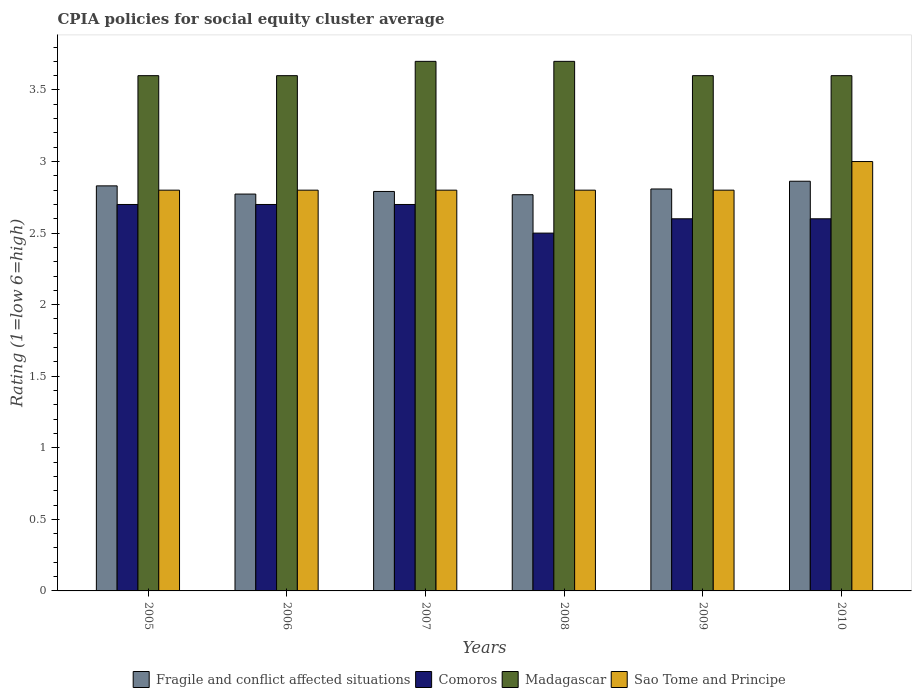How many groups of bars are there?
Provide a succinct answer. 6. Are the number of bars on each tick of the X-axis equal?
Your answer should be very brief. Yes. What is the label of the 6th group of bars from the left?
Offer a terse response. 2010. Across all years, what is the maximum CPIA rating in Fragile and conflict affected situations?
Your answer should be very brief. 2.86. Across all years, what is the minimum CPIA rating in Fragile and conflict affected situations?
Give a very brief answer. 2.77. In which year was the CPIA rating in Comoros minimum?
Make the answer very short. 2008. What is the total CPIA rating in Madagascar in the graph?
Your answer should be compact. 21.8. What is the difference between the CPIA rating in Sao Tome and Principe in 2005 and the CPIA rating in Madagascar in 2009?
Keep it short and to the point. -0.8. What is the average CPIA rating in Sao Tome and Principe per year?
Make the answer very short. 2.83. In the year 2009, what is the difference between the CPIA rating in Sao Tome and Principe and CPIA rating in Madagascar?
Your answer should be compact. -0.8. What is the ratio of the CPIA rating in Comoros in 2008 to that in 2009?
Ensure brevity in your answer.  0.96. Is the CPIA rating in Fragile and conflict affected situations in 2006 less than that in 2007?
Provide a short and direct response. Yes. What is the difference between the highest and the lowest CPIA rating in Sao Tome and Principe?
Provide a succinct answer. 0.2. Is the sum of the CPIA rating in Comoros in 2006 and 2010 greater than the maximum CPIA rating in Sao Tome and Principe across all years?
Your answer should be compact. Yes. What does the 2nd bar from the left in 2010 represents?
Provide a succinct answer. Comoros. What does the 3rd bar from the right in 2008 represents?
Provide a short and direct response. Comoros. Is it the case that in every year, the sum of the CPIA rating in Sao Tome and Principe and CPIA rating in Madagascar is greater than the CPIA rating in Comoros?
Your answer should be compact. Yes. How many years are there in the graph?
Your answer should be compact. 6. How are the legend labels stacked?
Keep it short and to the point. Horizontal. What is the title of the graph?
Your answer should be compact. CPIA policies for social equity cluster average. Does "Turks and Caicos Islands" appear as one of the legend labels in the graph?
Your answer should be compact. No. What is the Rating (1=low 6=high) of Fragile and conflict affected situations in 2005?
Provide a succinct answer. 2.83. What is the Rating (1=low 6=high) of Comoros in 2005?
Your answer should be very brief. 2.7. What is the Rating (1=low 6=high) of Madagascar in 2005?
Provide a succinct answer. 3.6. What is the Rating (1=low 6=high) of Sao Tome and Principe in 2005?
Your answer should be very brief. 2.8. What is the Rating (1=low 6=high) of Fragile and conflict affected situations in 2006?
Give a very brief answer. 2.77. What is the Rating (1=low 6=high) of Comoros in 2006?
Your answer should be very brief. 2.7. What is the Rating (1=low 6=high) in Sao Tome and Principe in 2006?
Your answer should be compact. 2.8. What is the Rating (1=low 6=high) in Fragile and conflict affected situations in 2007?
Your answer should be compact. 2.79. What is the Rating (1=low 6=high) of Madagascar in 2007?
Offer a terse response. 3.7. What is the Rating (1=low 6=high) of Fragile and conflict affected situations in 2008?
Your answer should be very brief. 2.77. What is the Rating (1=low 6=high) in Madagascar in 2008?
Your answer should be very brief. 3.7. What is the Rating (1=low 6=high) in Fragile and conflict affected situations in 2009?
Provide a short and direct response. 2.81. What is the Rating (1=low 6=high) in Comoros in 2009?
Give a very brief answer. 2.6. What is the Rating (1=low 6=high) in Fragile and conflict affected situations in 2010?
Your answer should be very brief. 2.86. What is the Rating (1=low 6=high) of Comoros in 2010?
Offer a very short reply. 2.6. Across all years, what is the maximum Rating (1=low 6=high) in Fragile and conflict affected situations?
Your answer should be compact. 2.86. Across all years, what is the minimum Rating (1=low 6=high) of Fragile and conflict affected situations?
Provide a short and direct response. 2.77. What is the total Rating (1=low 6=high) in Fragile and conflict affected situations in the graph?
Give a very brief answer. 16.83. What is the total Rating (1=low 6=high) in Comoros in the graph?
Ensure brevity in your answer.  15.8. What is the total Rating (1=low 6=high) in Madagascar in the graph?
Ensure brevity in your answer.  21.8. What is the total Rating (1=low 6=high) in Sao Tome and Principe in the graph?
Your response must be concise. 17. What is the difference between the Rating (1=low 6=high) in Fragile and conflict affected situations in 2005 and that in 2006?
Keep it short and to the point. 0.06. What is the difference between the Rating (1=low 6=high) in Comoros in 2005 and that in 2006?
Give a very brief answer. 0. What is the difference between the Rating (1=low 6=high) in Sao Tome and Principe in 2005 and that in 2006?
Provide a short and direct response. 0. What is the difference between the Rating (1=low 6=high) of Fragile and conflict affected situations in 2005 and that in 2007?
Offer a terse response. 0.04. What is the difference between the Rating (1=low 6=high) in Madagascar in 2005 and that in 2007?
Keep it short and to the point. -0.1. What is the difference between the Rating (1=low 6=high) of Sao Tome and Principe in 2005 and that in 2007?
Make the answer very short. 0. What is the difference between the Rating (1=low 6=high) of Fragile and conflict affected situations in 2005 and that in 2008?
Offer a very short reply. 0.06. What is the difference between the Rating (1=low 6=high) of Madagascar in 2005 and that in 2008?
Your response must be concise. -0.1. What is the difference between the Rating (1=low 6=high) in Fragile and conflict affected situations in 2005 and that in 2009?
Offer a very short reply. 0.02. What is the difference between the Rating (1=low 6=high) of Madagascar in 2005 and that in 2009?
Keep it short and to the point. 0. What is the difference between the Rating (1=low 6=high) of Sao Tome and Principe in 2005 and that in 2009?
Make the answer very short. 0. What is the difference between the Rating (1=low 6=high) in Fragile and conflict affected situations in 2005 and that in 2010?
Ensure brevity in your answer.  -0.03. What is the difference between the Rating (1=low 6=high) in Comoros in 2005 and that in 2010?
Provide a succinct answer. 0.1. What is the difference between the Rating (1=low 6=high) in Madagascar in 2005 and that in 2010?
Make the answer very short. 0. What is the difference between the Rating (1=low 6=high) in Fragile and conflict affected situations in 2006 and that in 2007?
Your response must be concise. -0.02. What is the difference between the Rating (1=low 6=high) of Comoros in 2006 and that in 2007?
Keep it short and to the point. 0. What is the difference between the Rating (1=low 6=high) of Madagascar in 2006 and that in 2007?
Make the answer very short. -0.1. What is the difference between the Rating (1=low 6=high) in Fragile and conflict affected situations in 2006 and that in 2008?
Your response must be concise. 0. What is the difference between the Rating (1=low 6=high) of Comoros in 2006 and that in 2008?
Your answer should be very brief. 0.2. What is the difference between the Rating (1=low 6=high) of Fragile and conflict affected situations in 2006 and that in 2009?
Your response must be concise. -0.04. What is the difference between the Rating (1=low 6=high) of Comoros in 2006 and that in 2009?
Offer a terse response. 0.1. What is the difference between the Rating (1=low 6=high) of Fragile and conflict affected situations in 2006 and that in 2010?
Your answer should be very brief. -0.09. What is the difference between the Rating (1=low 6=high) of Sao Tome and Principe in 2006 and that in 2010?
Your answer should be very brief. -0.2. What is the difference between the Rating (1=low 6=high) in Fragile and conflict affected situations in 2007 and that in 2008?
Your response must be concise. 0.02. What is the difference between the Rating (1=low 6=high) in Madagascar in 2007 and that in 2008?
Your response must be concise. 0. What is the difference between the Rating (1=low 6=high) of Fragile and conflict affected situations in 2007 and that in 2009?
Your answer should be very brief. -0.02. What is the difference between the Rating (1=low 6=high) of Comoros in 2007 and that in 2009?
Your answer should be very brief. 0.1. What is the difference between the Rating (1=low 6=high) of Fragile and conflict affected situations in 2007 and that in 2010?
Your answer should be very brief. -0.07. What is the difference between the Rating (1=low 6=high) in Comoros in 2007 and that in 2010?
Offer a very short reply. 0.1. What is the difference between the Rating (1=low 6=high) in Madagascar in 2007 and that in 2010?
Give a very brief answer. 0.1. What is the difference between the Rating (1=low 6=high) of Sao Tome and Principe in 2007 and that in 2010?
Your response must be concise. -0.2. What is the difference between the Rating (1=low 6=high) of Fragile and conflict affected situations in 2008 and that in 2009?
Keep it short and to the point. -0.04. What is the difference between the Rating (1=low 6=high) in Fragile and conflict affected situations in 2008 and that in 2010?
Provide a succinct answer. -0.09. What is the difference between the Rating (1=low 6=high) of Comoros in 2008 and that in 2010?
Keep it short and to the point. -0.1. What is the difference between the Rating (1=low 6=high) in Madagascar in 2008 and that in 2010?
Your answer should be very brief. 0.1. What is the difference between the Rating (1=low 6=high) in Sao Tome and Principe in 2008 and that in 2010?
Your answer should be compact. -0.2. What is the difference between the Rating (1=low 6=high) of Fragile and conflict affected situations in 2009 and that in 2010?
Ensure brevity in your answer.  -0.05. What is the difference between the Rating (1=low 6=high) in Madagascar in 2009 and that in 2010?
Provide a short and direct response. 0. What is the difference between the Rating (1=low 6=high) of Sao Tome and Principe in 2009 and that in 2010?
Your response must be concise. -0.2. What is the difference between the Rating (1=low 6=high) of Fragile and conflict affected situations in 2005 and the Rating (1=low 6=high) of Comoros in 2006?
Offer a very short reply. 0.13. What is the difference between the Rating (1=low 6=high) of Fragile and conflict affected situations in 2005 and the Rating (1=low 6=high) of Madagascar in 2006?
Your answer should be very brief. -0.77. What is the difference between the Rating (1=low 6=high) in Comoros in 2005 and the Rating (1=low 6=high) in Madagascar in 2006?
Your response must be concise. -0.9. What is the difference between the Rating (1=low 6=high) in Comoros in 2005 and the Rating (1=low 6=high) in Sao Tome and Principe in 2006?
Offer a very short reply. -0.1. What is the difference between the Rating (1=low 6=high) in Madagascar in 2005 and the Rating (1=low 6=high) in Sao Tome and Principe in 2006?
Offer a terse response. 0.8. What is the difference between the Rating (1=low 6=high) in Fragile and conflict affected situations in 2005 and the Rating (1=low 6=high) in Comoros in 2007?
Provide a short and direct response. 0.13. What is the difference between the Rating (1=low 6=high) of Fragile and conflict affected situations in 2005 and the Rating (1=low 6=high) of Madagascar in 2007?
Provide a succinct answer. -0.87. What is the difference between the Rating (1=low 6=high) of Fragile and conflict affected situations in 2005 and the Rating (1=low 6=high) of Sao Tome and Principe in 2007?
Your answer should be very brief. 0.03. What is the difference between the Rating (1=low 6=high) of Comoros in 2005 and the Rating (1=low 6=high) of Madagascar in 2007?
Keep it short and to the point. -1. What is the difference between the Rating (1=low 6=high) in Comoros in 2005 and the Rating (1=low 6=high) in Sao Tome and Principe in 2007?
Your response must be concise. -0.1. What is the difference between the Rating (1=low 6=high) of Madagascar in 2005 and the Rating (1=low 6=high) of Sao Tome and Principe in 2007?
Your answer should be very brief. 0.8. What is the difference between the Rating (1=low 6=high) of Fragile and conflict affected situations in 2005 and the Rating (1=low 6=high) of Comoros in 2008?
Offer a very short reply. 0.33. What is the difference between the Rating (1=low 6=high) of Fragile and conflict affected situations in 2005 and the Rating (1=low 6=high) of Madagascar in 2008?
Offer a very short reply. -0.87. What is the difference between the Rating (1=low 6=high) of Fragile and conflict affected situations in 2005 and the Rating (1=low 6=high) of Sao Tome and Principe in 2008?
Provide a short and direct response. 0.03. What is the difference between the Rating (1=low 6=high) of Comoros in 2005 and the Rating (1=low 6=high) of Sao Tome and Principe in 2008?
Offer a terse response. -0.1. What is the difference between the Rating (1=low 6=high) in Fragile and conflict affected situations in 2005 and the Rating (1=low 6=high) in Comoros in 2009?
Offer a terse response. 0.23. What is the difference between the Rating (1=low 6=high) of Fragile and conflict affected situations in 2005 and the Rating (1=low 6=high) of Madagascar in 2009?
Your response must be concise. -0.77. What is the difference between the Rating (1=low 6=high) in Fragile and conflict affected situations in 2005 and the Rating (1=low 6=high) in Sao Tome and Principe in 2009?
Provide a succinct answer. 0.03. What is the difference between the Rating (1=low 6=high) in Comoros in 2005 and the Rating (1=low 6=high) in Madagascar in 2009?
Your answer should be very brief. -0.9. What is the difference between the Rating (1=low 6=high) of Madagascar in 2005 and the Rating (1=low 6=high) of Sao Tome and Principe in 2009?
Ensure brevity in your answer.  0.8. What is the difference between the Rating (1=low 6=high) of Fragile and conflict affected situations in 2005 and the Rating (1=low 6=high) of Comoros in 2010?
Your answer should be very brief. 0.23. What is the difference between the Rating (1=low 6=high) of Fragile and conflict affected situations in 2005 and the Rating (1=low 6=high) of Madagascar in 2010?
Your response must be concise. -0.77. What is the difference between the Rating (1=low 6=high) of Fragile and conflict affected situations in 2005 and the Rating (1=low 6=high) of Sao Tome and Principe in 2010?
Offer a very short reply. -0.17. What is the difference between the Rating (1=low 6=high) in Comoros in 2005 and the Rating (1=low 6=high) in Madagascar in 2010?
Provide a short and direct response. -0.9. What is the difference between the Rating (1=low 6=high) of Fragile and conflict affected situations in 2006 and the Rating (1=low 6=high) of Comoros in 2007?
Keep it short and to the point. 0.07. What is the difference between the Rating (1=low 6=high) in Fragile and conflict affected situations in 2006 and the Rating (1=low 6=high) in Madagascar in 2007?
Make the answer very short. -0.93. What is the difference between the Rating (1=low 6=high) in Fragile and conflict affected situations in 2006 and the Rating (1=low 6=high) in Sao Tome and Principe in 2007?
Provide a succinct answer. -0.03. What is the difference between the Rating (1=low 6=high) of Fragile and conflict affected situations in 2006 and the Rating (1=low 6=high) of Comoros in 2008?
Give a very brief answer. 0.27. What is the difference between the Rating (1=low 6=high) of Fragile and conflict affected situations in 2006 and the Rating (1=low 6=high) of Madagascar in 2008?
Offer a terse response. -0.93. What is the difference between the Rating (1=low 6=high) in Fragile and conflict affected situations in 2006 and the Rating (1=low 6=high) in Sao Tome and Principe in 2008?
Offer a terse response. -0.03. What is the difference between the Rating (1=low 6=high) in Comoros in 2006 and the Rating (1=low 6=high) in Madagascar in 2008?
Keep it short and to the point. -1. What is the difference between the Rating (1=low 6=high) in Comoros in 2006 and the Rating (1=low 6=high) in Sao Tome and Principe in 2008?
Provide a short and direct response. -0.1. What is the difference between the Rating (1=low 6=high) of Fragile and conflict affected situations in 2006 and the Rating (1=low 6=high) of Comoros in 2009?
Provide a short and direct response. 0.17. What is the difference between the Rating (1=low 6=high) of Fragile and conflict affected situations in 2006 and the Rating (1=low 6=high) of Madagascar in 2009?
Ensure brevity in your answer.  -0.83. What is the difference between the Rating (1=low 6=high) in Fragile and conflict affected situations in 2006 and the Rating (1=low 6=high) in Sao Tome and Principe in 2009?
Your answer should be very brief. -0.03. What is the difference between the Rating (1=low 6=high) of Comoros in 2006 and the Rating (1=low 6=high) of Madagascar in 2009?
Your answer should be compact. -0.9. What is the difference between the Rating (1=low 6=high) of Madagascar in 2006 and the Rating (1=low 6=high) of Sao Tome and Principe in 2009?
Give a very brief answer. 0.8. What is the difference between the Rating (1=low 6=high) in Fragile and conflict affected situations in 2006 and the Rating (1=low 6=high) in Comoros in 2010?
Your answer should be compact. 0.17. What is the difference between the Rating (1=low 6=high) in Fragile and conflict affected situations in 2006 and the Rating (1=low 6=high) in Madagascar in 2010?
Your answer should be very brief. -0.83. What is the difference between the Rating (1=low 6=high) in Fragile and conflict affected situations in 2006 and the Rating (1=low 6=high) in Sao Tome and Principe in 2010?
Offer a terse response. -0.23. What is the difference between the Rating (1=low 6=high) in Fragile and conflict affected situations in 2007 and the Rating (1=low 6=high) in Comoros in 2008?
Make the answer very short. 0.29. What is the difference between the Rating (1=low 6=high) of Fragile and conflict affected situations in 2007 and the Rating (1=low 6=high) of Madagascar in 2008?
Provide a succinct answer. -0.91. What is the difference between the Rating (1=low 6=high) of Fragile and conflict affected situations in 2007 and the Rating (1=low 6=high) of Sao Tome and Principe in 2008?
Keep it short and to the point. -0.01. What is the difference between the Rating (1=low 6=high) of Comoros in 2007 and the Rating (1=low 6=high) of Madagascar in 2008?
Provide a short and direct response. -1. What is the difference between the Rating (1=low 6=high) of Comoros in 2007 and the Rating (1=low 6=high) of Sao Tome and Principe in 2008?
Your answer should be very brief. -0.1. What is the difference between the Rating (1=low 6=high) in Madagascar in 2007 and the Rating (1=low 6=high) in Sao Tome and Principe in 2008?
Make the answer very short. 0.9. What is the difference between the Rating (1=low 6=high) in Fragile and conflict affected situations in 2007 and the Rating (1=low 6=high) in Comoros in 2009?
Your answer should be very brief. 0.19. What is the difference between the Rating (1=low 6=high) of Fragile and conflict affected situations in 2007 and the Rating (1=low 6=high) of Madagascar in 2009?
Ensure brevity in your answer.  -0.81. What is the difference between the Rating (1=low 6=high) of Fragile and conflict affected situations in 2007 and the Rating (1=low 6=high) of Sao Tome and Principe in 2009?
Your answer should be compact. -0.01. What is the difference between the Rating (1=low 6=high) in Comoros in 2007 and the Rating (1=low 6=high) in Madagascar in 2009?
Your answer should be very brief. -0.9. What is the difference between the Rating (1=low 6=high) of Comoros in 2007 and the Rating (1=low 6=high) of Sao Tome and Principe in 2009?
Provide a short and direct response. -0.1. What is the difference between the Rating (1=low 6=high) in Fragile and conflict affected situations in 2007 and the Rating (1=low 6=high) in Comoros in 2010?
Offer a terse response. 0.19. What is the difference between the Rating (1=low 6=high) of Fragile and conflict affected situations in 2007 and the Rating (1=low 6=high) of Madagascar in 2010?
Keep it short and to the point. -0.81. What is the difference between the Rating (1=low 6=high) of Fragile and conflict affected situations in 2007 and the Rating (1=low 6=high) of Sao Tome and Principe in 2010?
Offer a terse response. -0.21. What is the difference between the Rating (1=low 6=high) of Madagascar in 2007 and the Rating (1=low 6=high) of Sao Tome and Principe in 2010?
Provide a short and direct response. 0.7. What is the difference between the Rating (1=low 6=high) in Fragile and conflict affected situations in 2008 and the Rating (1=low 6=high) in Comoros in 2009?
Your answer should be compact. 0.17. What is the difference between the Rating (1=low 6=high) of Fragile and conflict affected situations in 2008 and the Rating (1=low 6=high) of Madagascar in 2009?
Give a very brief answer. -0.83. What is the difference between the Rating (1=low 6=high) of Fragile and conflict affected situations in 2008 and the Rating (1=low 6=high) of Sao Tome and Principe in 2009?
Your response must be concise. -0.03. What is the difference between the Rating (1=low 6=high) in Fragile and conflict affected situations in 2008 and the Rating (1=low 6=high) in Comoros in 2010?
Offer a very short reply. 0.17. What is the difference between the Rating (1=low 6=high) in Fragile and conflict affected situations in 2008 and the Rating (1=low 6=high) in Madagascar in 2010?
Your response must be concise. -0.83. What is the difference between the Rating (1=low 6=high) in Fragile and conflict affected situations in 2008 and the Rating (1=low 6=high) in Sao Tome and Principe in 2010?
Give a very brief answer. -0.23. What is the difference between the Rating (1=low 6=high) of Comoros in 2008 and the Rating (1=low 6=high) of Madagascar in 2010?
Your answer should be very brief. -1.1. What is the difference between the Rating (1=low 6=high) of Comoros in 2008 and the Rating (1=low 6=high) of Sao Tome and Principe in 2010?
Your answer should be very brief. -0.5. What is the difference between the Rating (1=low 6=high) in Madagascar in 2008 and the Rating (1=low 6=high) in Sao Tome and Principe in 2010?
Ensure brevity in your answer.  0.7. What is the difference between the Rating (1=low 6=high) of Fragile and conflict affected situations in 2009 and the Rating (1=low 6=high) of Comoros in 2010?
Keep it short and to the point. 0.21. What is the difference between the Rating (1=low 6=high) of Fragile and conflict affected situations in 2009 and the Rating (1=low 6=high) of Madagascar in 2010?
Provide a succinct answer. -0.79. What is the difference between the Rating (1=low 6=high) of Fragile and conflict affected situations in 2009 and the Rating (1=low 6=high) of Sao Tome and Principe in 2010?
Ensure brevity in your answer.  -0.19. What is the difference between the Rating (1=low 6=high) in Comoros in 2009 and the Rating (1=low 6=high) in Madagascar in 2010?
Provide a succinct answer. -1. What is the difference between the Rating (1=low 6=high) of Comoros in 2009 and the Rating (1=low 6=high) of Sao Tome and Principe in 2010?
Offer a very short reply. -0.4. What is the average Rating (1=low 6=high) of Fragile and conflict affected situations per year?
Give a very brief answer. 2.81. What is the average Rating (1=low 6=high) in Comoros per year?
Provide a succinct answer. 2.63. What is the average Rating (1=low 6=high) in Madagascar per year?
Keep it short and to the point. 3.63. What is the average Rating (1=low 6=high) of Sao Tome and Principe per year?
Keep it short and to the point. 2.83. In the year 2005, what is the difference between the Rating (1=low 6=high) of Fragile and conflict affected situations and Rating (1=low 6=high) of Comoros?
Ensure brevity in your answer.  0.13. In the year 2005, what is the difference between the Rating (1=low 6=high) in Fragile and conflict affected situations and Rating (1=low 6=high) in Madagascar?
Offer a very short reply. -0.77. In the year 2006, what is the difference between the Rating (1=low 6=high) of Fragile and conflict affected situations and Rating (1=low 6=high) of Comoros?
Keep it short and to the point. 0.07. In the year 2006, what is the difference between the Rating (1=low 6=high) in Fragile and conflict affected situations and Rating (1=low 6=high) in Madagascar?
Keep it short and to the point. -0.83. In the year 2006, what is the difference between the Rating (1=low 6=high) of Fragile and conflict affected situations and Rating (1=low 6=high) of Sao Tome and Principe?
Offer a terse response. -0.03. In the year 2006, what is the difference between the Rating (1=low 6=high) of Comoros and Rating (1=low 6=high) of Sao Tome and Principe?
Give a very brief answer. -0.1. In the year 2006, what is the difference between the Rating (1=low 6=high) of Madagascar and Rating (1=low 6=high) of Sao Tome and Principe?
Make the answer very short. 0.8. In the year 2007, what is the difference between the Rating (1=low 6=high) in Fragile and conflict affected situations and Rating (1=low 6=high) in Comoros?
Keep it short and to the point. 0.09. In the year 2007, what is the difference between the Rating (1=low 6=high) in Fragile and conflict affected situations and Rating (1=low 6=high) in Madagascar?
Give a very brief answer. -0.91. In the year 2007, what is the difference between the Rating (1=low 6=high) of Fragile and conflict affected situations and Rating (1=low 6=high) of Sao Tome and Principe?
Keep it short and to the point. -0.01. In the year 2007, what is the difference between the Rating (1=low 6=high) of Comoros and Rating (1=low 6=high) of Sao Tome and Principe?
Your answer should be very brief. -0.1. In the year 2008, what is the difference between the Rating (1=low 6=high) in Fragile and conflict affected situations and Rating (1=low 6=high) in Comoros?
Ensure brevity in your answer.  0.27. In the year 2008, what is the difference between the Rating (1=low 6=high) in Fragile and conflict affected situations and Rating (1=low 6=high) in Madagascar?
Ensure brevity in your answer.  -0.93. In the year 2008, what is the difference between the Rating (1=low 6=high) of Fragile and conflict affected situations and Rating (1=low 6=high) of Sao Tome and Principe?
Your answer should be compact. -0.03. In the year 2008, what is the difference between the Rating (1=low 6=high) in Comoros and Rating (1=low 6=high) in Madagascar?
Keep it short and to the point. -1.2. In the year 2008, what is the difference between the Rating (1=low 6=high) in Comoros and Rating (1=low 6=high) in Sao Tome and Principe?
Make the answer very short. -0.3. In the year 2009, what is the difference between the Rating (1=low 6=high) in Fragile and conflict affected situations and Rating (1=low 6=high) in Comoros?
Give a very brief answer. 0.21. In the year 2009, what is the difference between the Rating (1=low 6=high) in Fragile and conflict affected situations and Rating (1=low 6=high) in Madagascar?
Offer a terse response. -0.79. In the year 2009, what is the difference between the Rating (1=low 6=high) of Fragile and conflict affected situations and Rating (1=low 6=high) of Sao Tome and Principe?
Provide a short and direct response. 0.01. In the year 2009, what is the difference between the Rating (1=low 6=high) of Comoros and Rating (1=low 6=high) of Sao Tome and Principe?
Provide a short and direct response. -0.2. In the year 2010, what is the difference between the Rating (1=low 6=high) in Fragile and conflict affected situations and Rating (1=low 6=high) in Comoros?
Offer a terse response. 0.26. In the year 2010, what is the difference between the Rating (1=low 6=high) in Fragile and conflict affected situations and Rating (1=low 6=high) in Madagascar?
Your response must be concise. -0.74. In the year 2010, what is the difference between the Rating (1=low 6=high) of Fragile and conflict affected situations and Rating (1=low 6=high) of Sao Tome and Principe?
Give a very brief answer. -0.14. In the year 2010, what is the difference between the Rating (1=low 6=high) of Comoros and Rating (1=low 6=high) of Sao Tome and Principe?
Give a very brief answer. -0.4. In the year 2010, what is the difference between the Rating (1=low 6=high) in Madagascar and Rating (1=low 6=high) in Sao Tome and Principe?
Provide a succinct answer. 0.6. What is the ratio of the Rating (1=low 6=high) of Fragile and conflict affected situations in 2005 to that in 2006?
Your response must be concise. 1.02. What is the ratio of the Rating (1=low 6=high) of Sao Tome and Principe in 2005 to that in 2006?
Your response must be concise. 1. What is the ratio of the Rating (1=low 6=high) in Comoros in 2005 to that in 2007?
Make the answer very short. 1. What is the ratio of the Rating (1=low 6=high) of Sao Tome and Principe in 2005 to that in 2007?
Your answer should be very brief. 1. What is the ratio of the Rating (1=low 6=high) in Fragile and conflict affected situations in 2005 to that in 2008?
Make the answer very short. 1.02. What is the ratio of the Rating (1=low 6=high) in Comoros in 2005 to that in 2008?
Provide a succinct answer. 1.08. What is the ratio of the Rating (1=low 6=high) in Sao Tome and Principe in 2005 to that in 2008?
Give a very brief answer. 1. What is the ratio of the Rating (1=low 6=high) in Fragile and conflict affected situations in 2005 to that in 2009?
Keep it short and to the point. 1.01. What is the ratio of the Rating (1=low 6=high) in Comoros in 2005 to that in 2009?
Make the answer very short. 1.04. What is the ratio of the Rating (1=low 6=high) of Madagascar in 2005 to that in 2010?
Give a very brief answer. 1. What is the ratio of the Rating (1=low 6=high) in Sao Tome and Principe in 2005 to that in 2010?
Offer a very short reply. 0.93. What is the ratio of the Rating (1=low 6=high) in Fragile and conflict affected situations in 2006 to that in 2008?
Your answer should be compact. 1. What is the ratio of the Rating (1=low 6=high) of Comoros in 2006 to that in 2008?
Make the answer very short. 1.08. What is the ratio of the Rating (1=low 6=high) of Sao Tome and Principe in 2006 to that in 2008?
Offer a very short reply. 1. What is the ratio of the Rating (1=low 6=high) in Fragile and conflict affected situations in 2006 to that in 2009?
Offer a terse response. 0.99. What is the ratio of the Rating (1=low 6=high) of Comoros in 2006 to that in 2009?
Your answer should be very brief. 1.04. What is the ratio of the Rating (1=low 6=high) of Fragile and conflict affected situations in 2006 to that in 2010?
Provide a short and direct response. 0.97. What is the ratio of the Rating (1=low 6=high) of Comoros in 2006 to that in 2010?
Give a very brief answer. 1.04. What is the ratio of the Rating (1=low 6=high) in Madagascar in 2006 to that in 2010?
Keep it short and to the point. 1. What is the ratio of the Rating (1=low 6=high) of Fragile and conflict affected situations in 2007 to that in 2008?
Offer a terse response. 1.01. What is the ratio of the Rating (1=low 6=high) of Comoros in 2007 to that in 2008?
Your response must be concise. 1.08. What is the ratio of the Rating (1=low 6=high) in Madagascar in 2007 to that in 2008?
Ensure brevity in your answer.  1. What is the ratio of the Rating (1=low 6=high) of Comoros in 2007 to that in 2009?
Give a very brief answer. 1.04. What is the ratio of the Rating (1=low 6=high) of Madagascar in 2007 to that in 2009?
Provide a succinct answer. 1.03. What is the ratio of the Rating (1=low 6=high) of Sao Tome and Principe in 2007 to that in 2009?
Provide a succinct answer. 1. What is the ratio of the Rating (1=low 6=high) of Fragile and conflict affected situations in 2007 to that in 2010?
Provide a succinct answer. 0.97. What is the ratio of the Rating (1=low 6=high) in Madagascar in 2007 to that in 2010?
Give a very brief answer. 1.03. What is the ratio of the Rating (1=low 6=high) of Fragile and conflict affected situations in 2008 to that in 2009?
Keep it short and to the point. 0.99. What is the ratio of the Rating (1=low 6=high) of Comoros in 2008 to that in 2009?
Your response must be concise. 0.96. What is the ratio of the Rating (1=low 6=high) of Madagascar in 2008 to that in 2009?
Your response must be concise. 1.03. What is the ratio of the Rating (1=low 6=high) in Fragile and conflict affected situations in 2008 to that in 2010?
Give a very brief answer. 0.97. What is the ratio of the Rating (1=low 6=high) in Comoros in 2008 to that in 2010?
Your response must be concise. 0.96. What is the ratio of the Rating (1=low 6=high) in Madagascar in 2008 to that in 2010?
Provide a short and direct response. 1.03. What is the ratio of the Rating (1=low 6=high) of Sao Tome and Principe in 2008 to that in 2010?
Give a very brief answer. 0.93. What is the ratio of the Rating (1=low 6=high) in Fragile and conflict affected situations in 2009 to that in 2010?
Your answer should be compact. 0.98. What is the ratio of the Rating (1=low 6=high) of Madagascar in 2009 to that in 2010?
Make the answer very short. 1. What is the ratio of the Rating (1=low 6=high) in Sao Tome and Principe in 2009 to that in 2010?
Your answer should be very brief. 0.93. What is the difference between the highest and the second highest Rating (1=low 6=high) in Fragile and conflict affected situations?
Keep it short and to the point. 0.03. What is the difference between the highest and the second highest Rating (1=low 6=high) of Madagascar?
Your answer should be very brief. 0. What is the difference between the highest and the lowest Rating (1=low 6=high) in Fragile and conflict affected situations?
Provide a succinct answer. 0.09. 